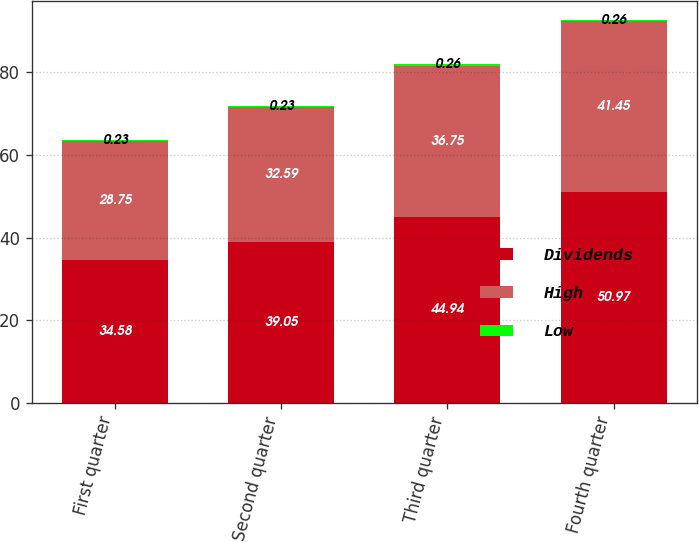Convert chart to OTSL. <chart><loc_0><loc_0><loc_500><loc_500><stacked_bar_chart><ecel><fcel>First quarter<fcel>Second quarter<fcel>Third quarter<fcel>Fourth quarter<nl><fcel>Dividends<fcel>34.58<fcel>39.05<fcel>44.94<fcel>50.97<nl><fcel>High<fcel>28.75<fcel>32.59<fcel>36.75<fcel>41.45<nl><fcel>Low<fcel>0.23<fcel>0.23<fcel>0.26<fcel>0.26<nl></chart> 